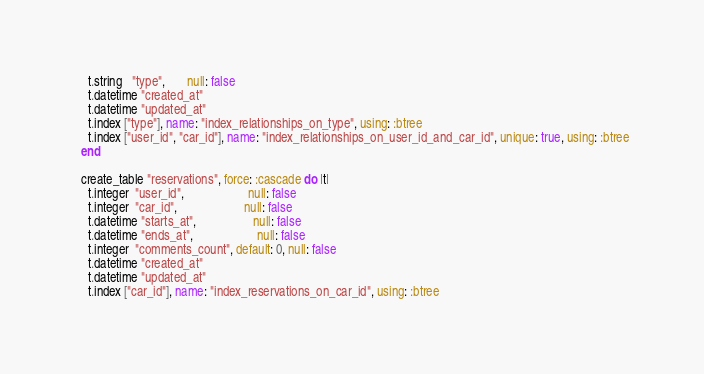<code> <loc_0><loc_0><loc_500><loc_500><_Ruby_>    t.string   "type",       null: false
    t.datetime "created_at"
    t.datetime "updated_at"
    t.index ["type"], name: "index_relationships_on_type", using: :btree
    t.index ["user_id", "car_id"], name: "index_relationships_on_user_id_and_car_id", unique: true, using: :btree
  end

  create_table "reservations", force: :cascade do |t|
    t.integer  "user_id",                    null: false
    t.integer  "car_id",                     null: false
    t.datetime "starts_at",                  null: false
    t.datetime "ends_at",                    null: false
    t.integer  "comments_count", default: 0, null: false
    t.datetime "created_at"
    t.datetime "updated_at"
    t.index ["car_id"], name: "index_reservations_on_car_id", using: :btree</code> 